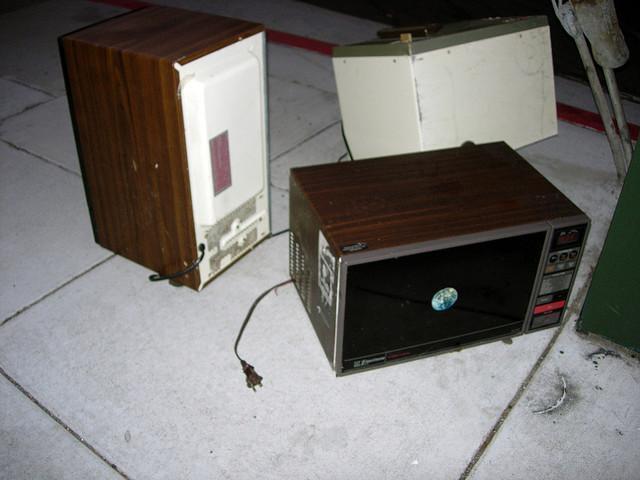How many microwaves are visible?
Give a very brief answer. 2. 